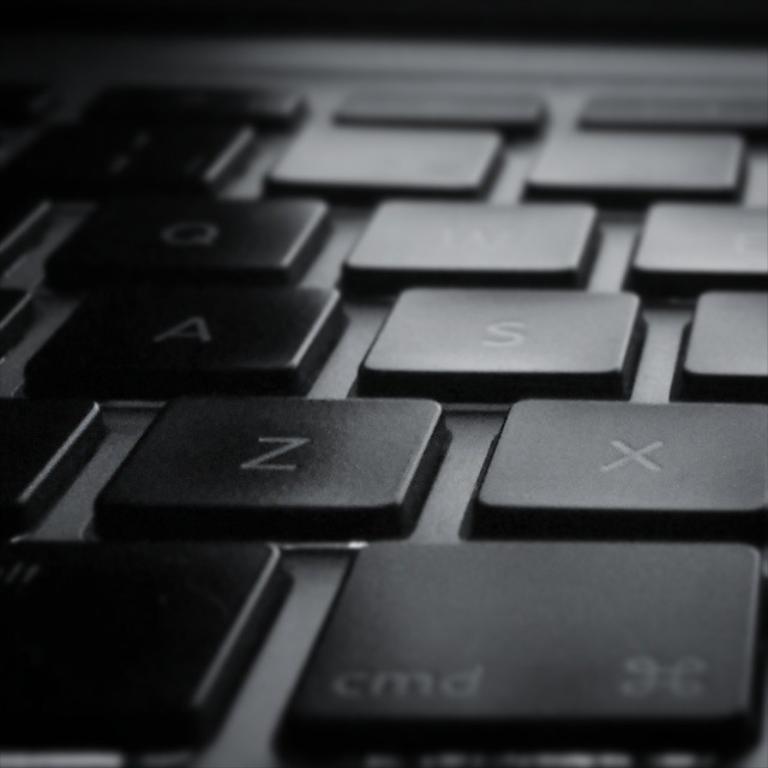What letter is to the right of z?
Offer a very short reply. X. What color are these keys?
Ensure brevity in your answer.  Black. 